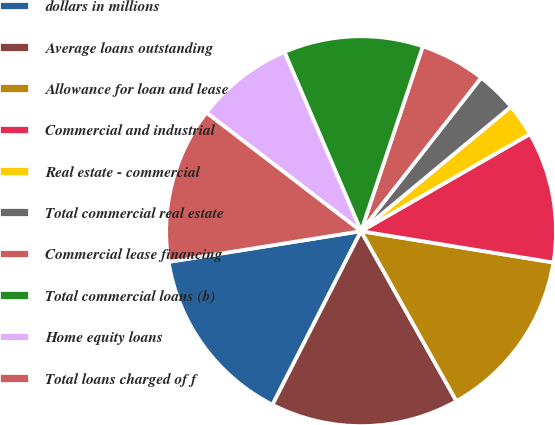Convert chart. <chart><loc_0><loc_0><loc_500><loc_500><pie_chart><fcel>dollars in millions<fcel>Average loans outstanding<fcel>Allowance for loan and lease<fcel>Commercial and industrial<fcel>Real estate - commercial<fcel>Total commercial real estate<fcel>Commercial lease financing<fcel>Total commercial loans (b)<fcel>Home equity loans<fcel>Total loans charged of f<nl><fcel>14.97%<fcel>15.65%<fcel>14.29%<fcel>10.88%<fcel>2.72%<fcel>3.4%<fcel>5.44%<fcel>11.56%<fcel>8.16%<fcel>12.93%<nl></chart> 